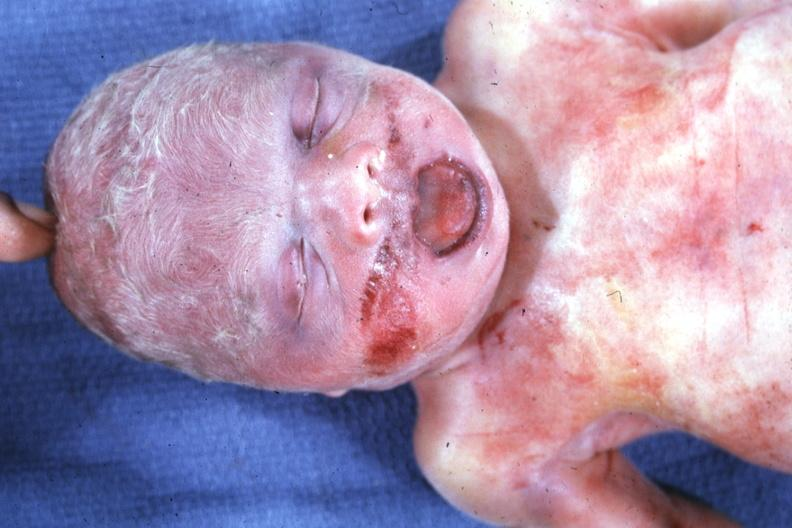what is present?
Answer the question using a single word or phrase. Face 